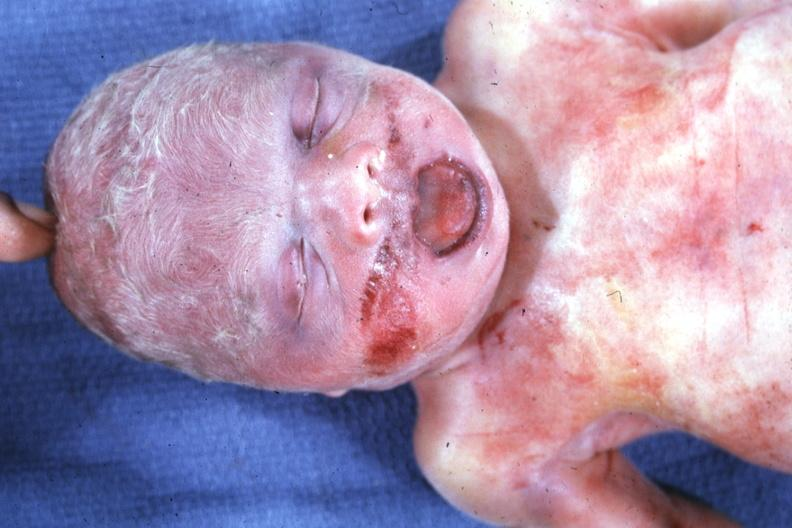what is present?
Answer the question using a single word or phrase. Face 